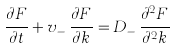<formula> <loc_0><loc_0><loc_500><loc_500>\frac { \partial F } { \partial t } + v _ { - } \, \frac { \partial F } { \partial k } = D _ { - } \, \frac { \partial ^ { 2 } F } { \partial ^ { 2 } k }</formula> 